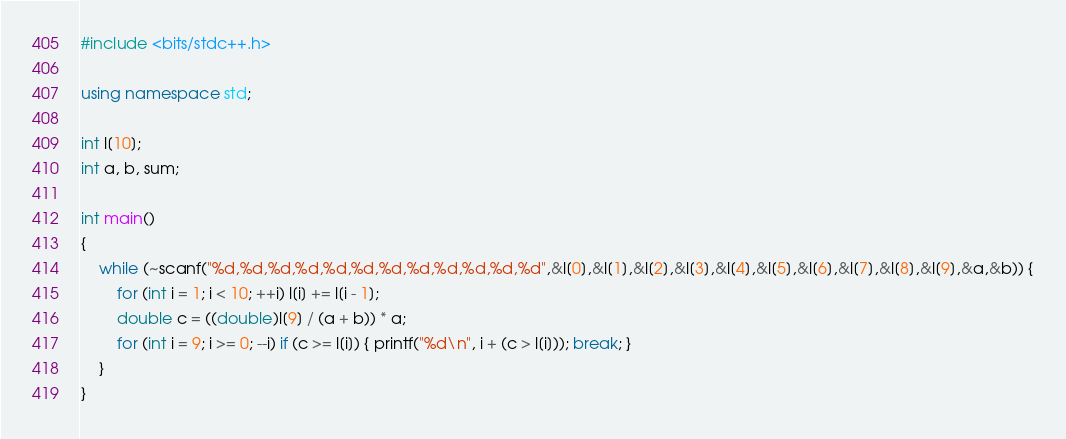Convert code to text. <code><loc_0><loc_0><loc_500><loc_500><_C++_>#include <bits/stdc++.h>

using namespace std;

int l[10];
int a, b, sum;

int main()
{
    while (~scanf("%d,%d,%d,%d,%d,%d,%d,%d,%d,%d,%d,%d",&l[0],&l[1],&l[2],&l[3],&l[4],&l[5],&l[6],&l[7],&l[8],&l[9],&a,&b)) {
        for (int i = 1; i < 10; ++i) l[i] += l[i - 1];
        double c = ((double)l[9] / (a + b)) * a;
        for (int i = 9; i >= 0; --i) if (c >= l[i]) { printf("%d\n", i + (c > l[i])); break; }
    }
}</code> 